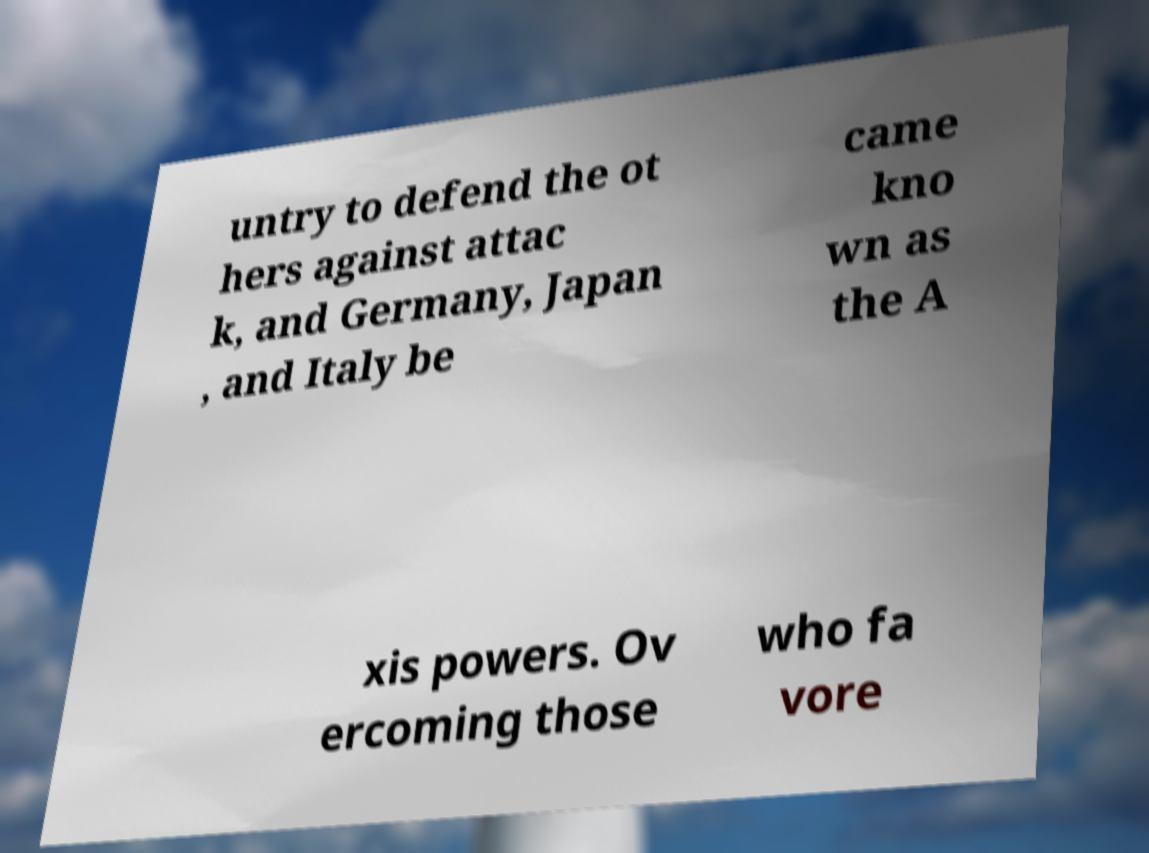I need the written content from this picture converted into text. Can you do that? untry to defend the ot hers against attac k, and Germany, Japan , and Italy be came kno wn as the A xis powers. Ov ercoming those who fa vore 